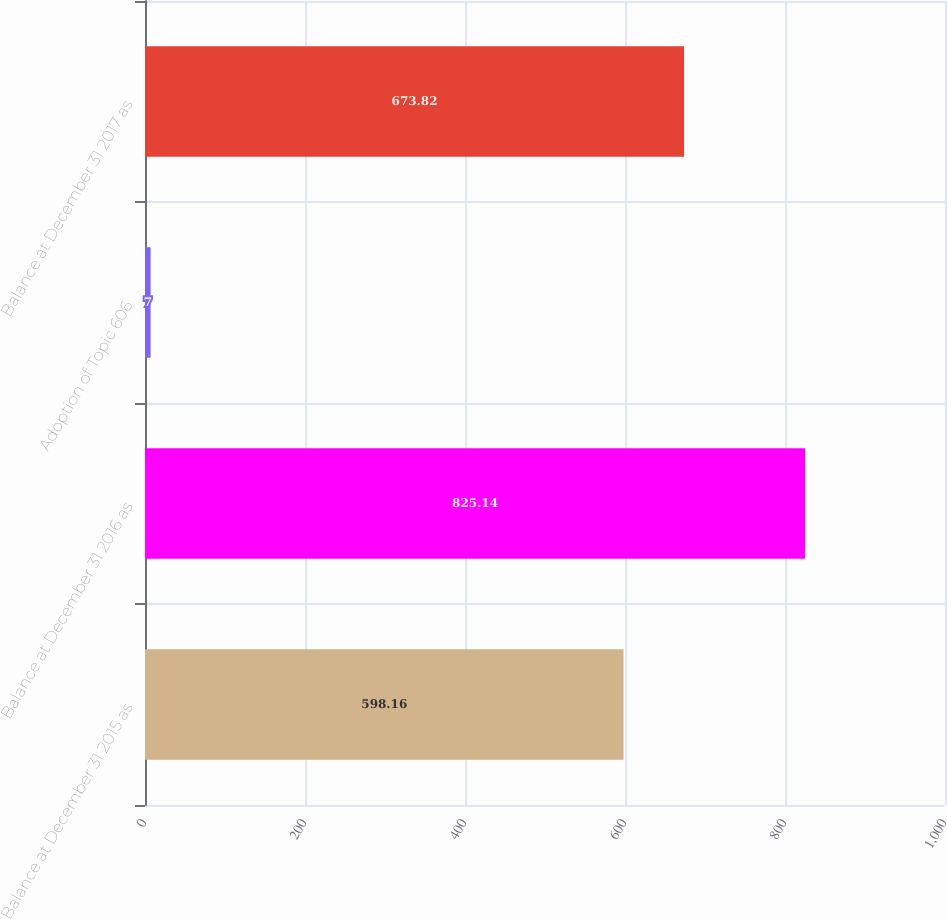Convert chart to OTSL. <chart><loc_0><loc_0><loc_500><loc_500><bar_chart><fcel>Balance at December 31 2015 as<fcel>Balance at December 31 2016 as<fcel>Adoption of Topic 606<fcel>Balance at December 31 2017 as<nl><fcel>598.16<fcel>825.14<fcel>7<fcel>673.82<nl></chart> 